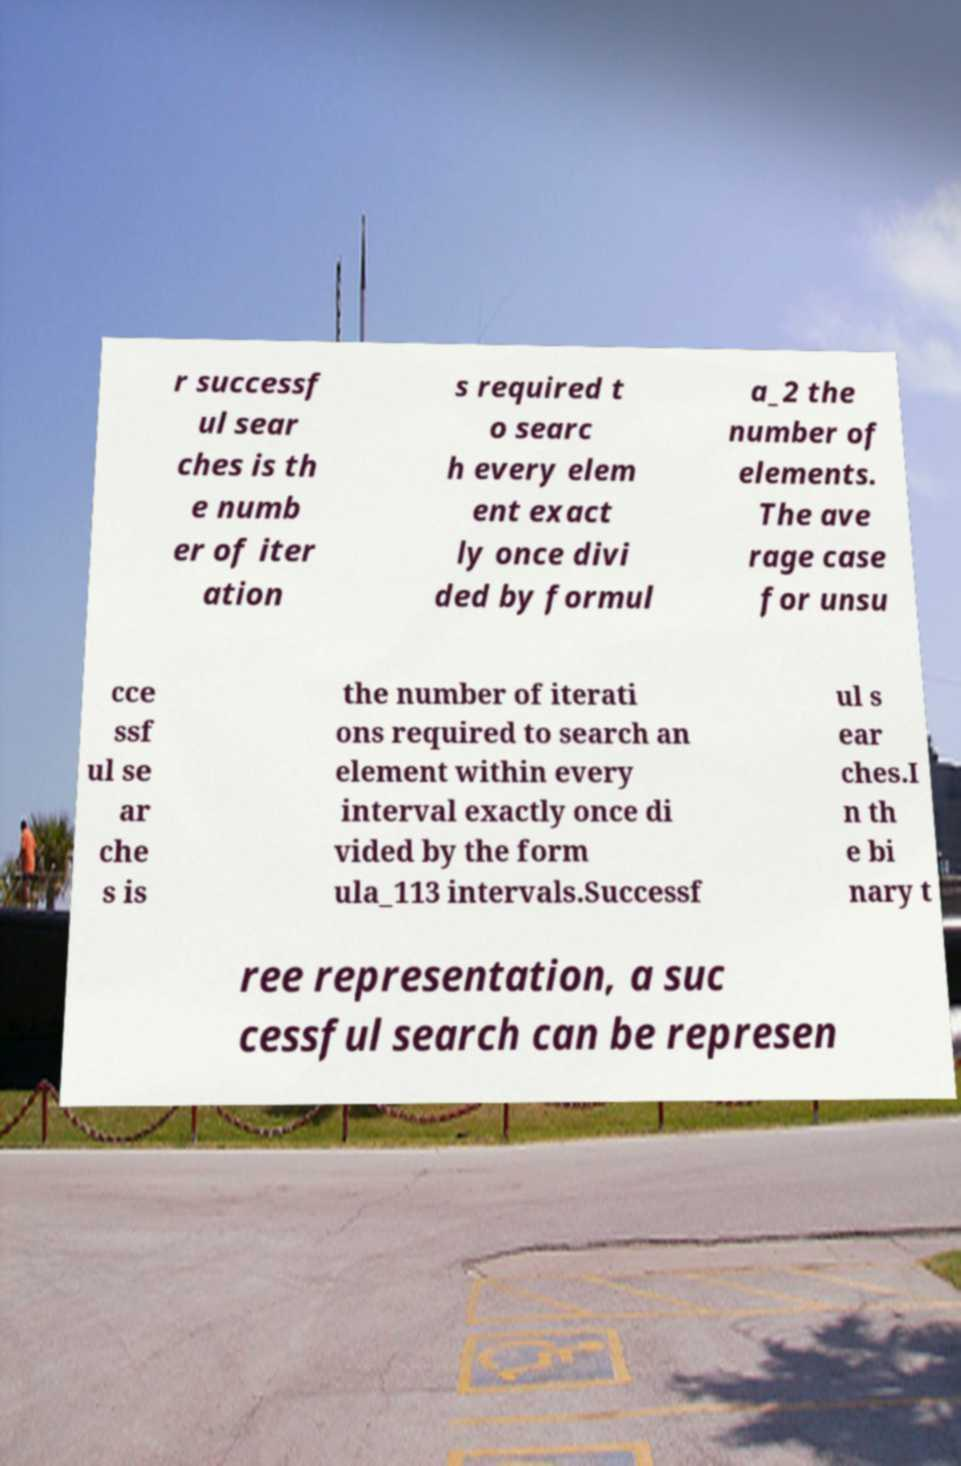Please identify and transcribe the text found in this image. r successf ul sear ches is th e numb er of iter ation s required t o searc h every elem ent exact ly once divi ded by formul a_2 the number of elements. The ave rage case for unsu cce ssf ul se ar che s is the number of iterati ons required to search an element within every interval exactly once di vided by the form ula_113 intervals.Successf ul s ear ches.I n th e bi nary t ree representation, a suc cessful search can be represen 